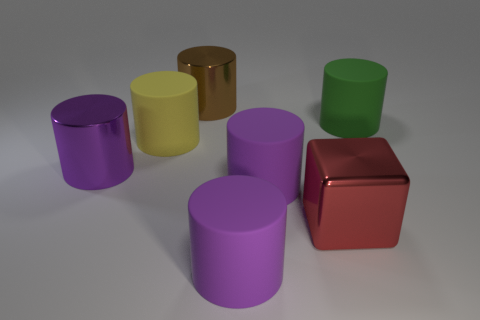Is the large red object the same shape as the big brown thing? No, they are not the same shape. The large red object is a cube, while the big brown thing appears to be a cylindrical shape. 